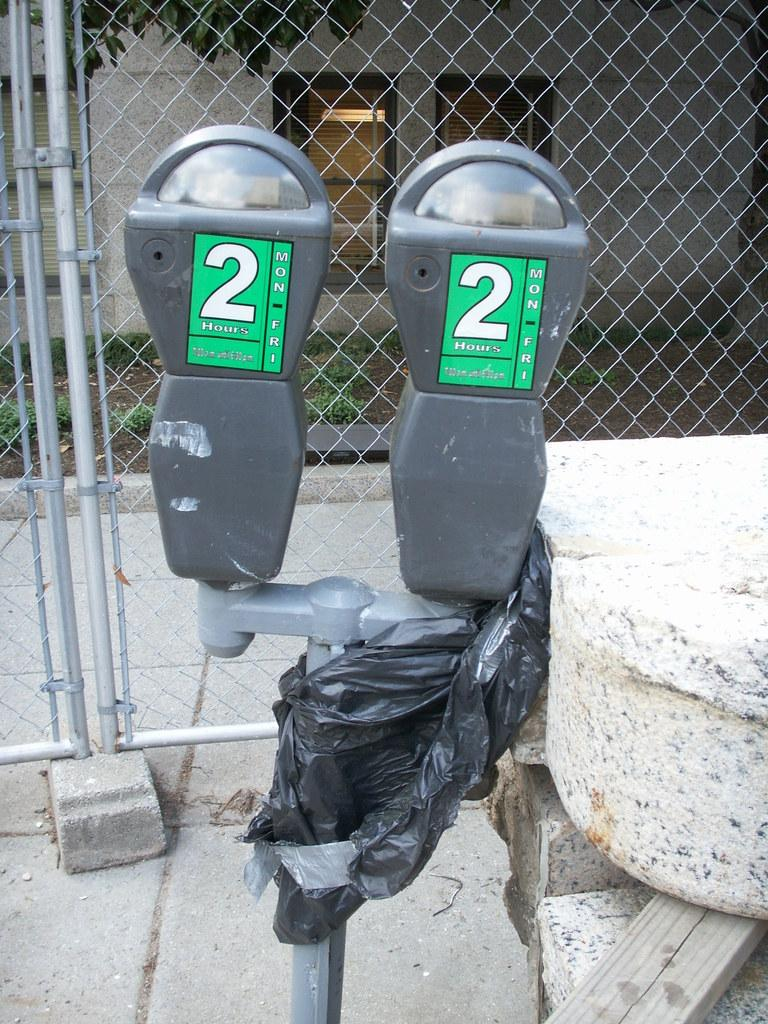<image>
Describe the image concisely. Two parking meters have a green label with 2 on the front. 